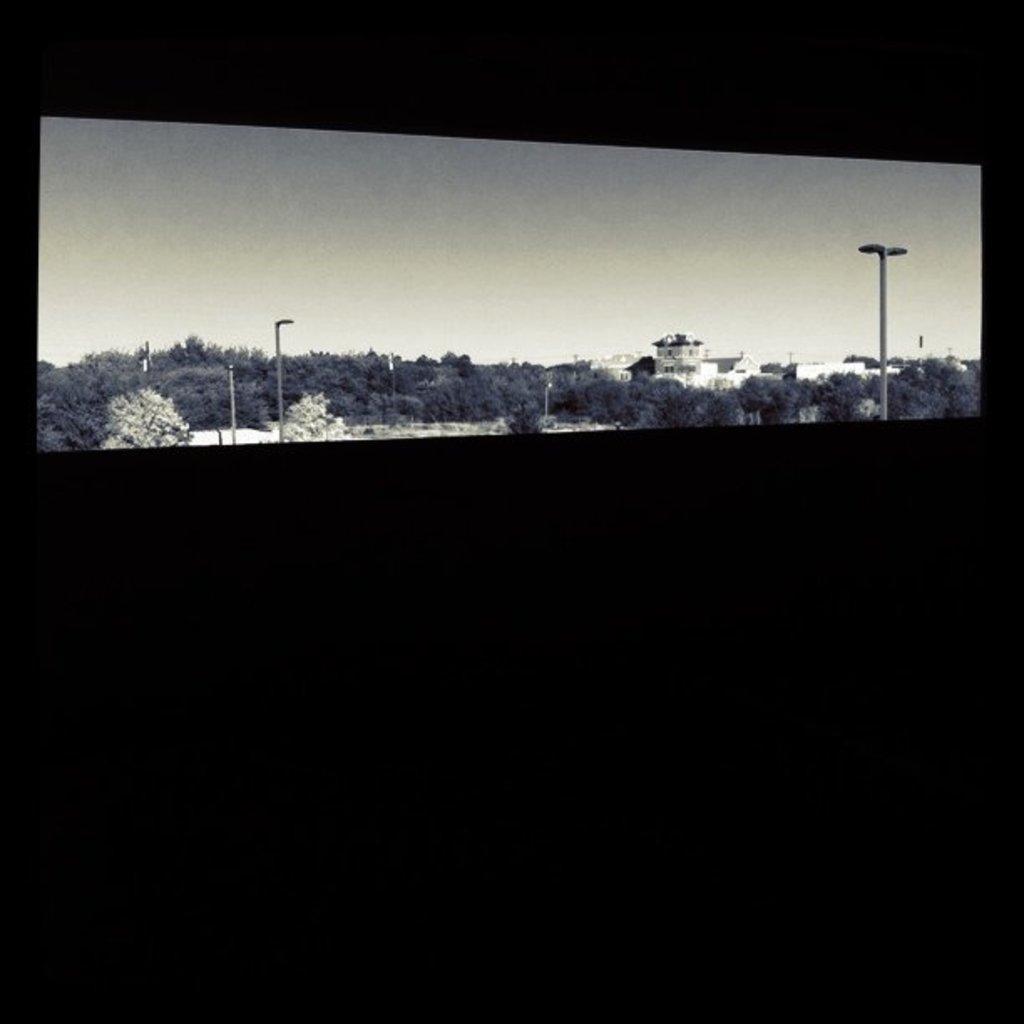In one or two sentences, can you explain what this image depicts? In the middle of the picture, there are many trees and buildings. We even see street lights and in the background, we see the sky. At the bottom of the picture, it is black in color. 